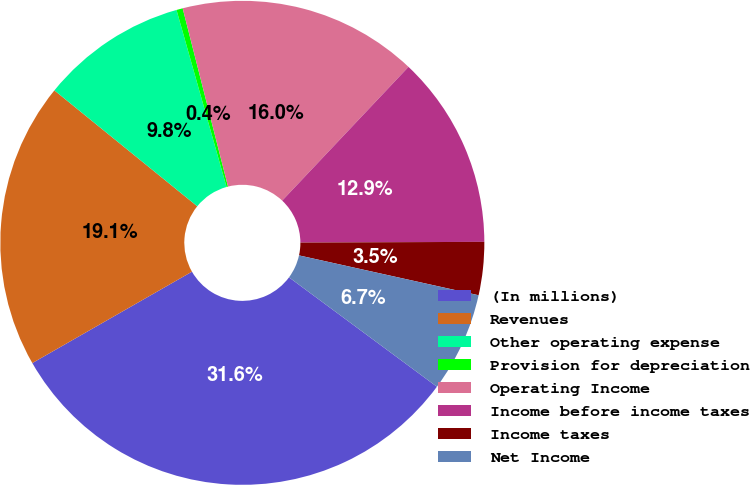<chart> <loc_0><loc_0><loc_500><loc_500><pie_chart><fcel>(In millions)<fcel>Revenues<fcel>Other operating expense<fcel>Provision for depreciation<fcel>Operating Income<fcel>Income before income taxes<fcel>Income taxes<fcel>Net Income<nl><fcel>31.59%<fcel>19.12%<fcel>9.77%<fcel>0.42%<fcel>16.01%<fcel>12.89%<fcel>3.54%<fcel>6.66%<nl></chart> 